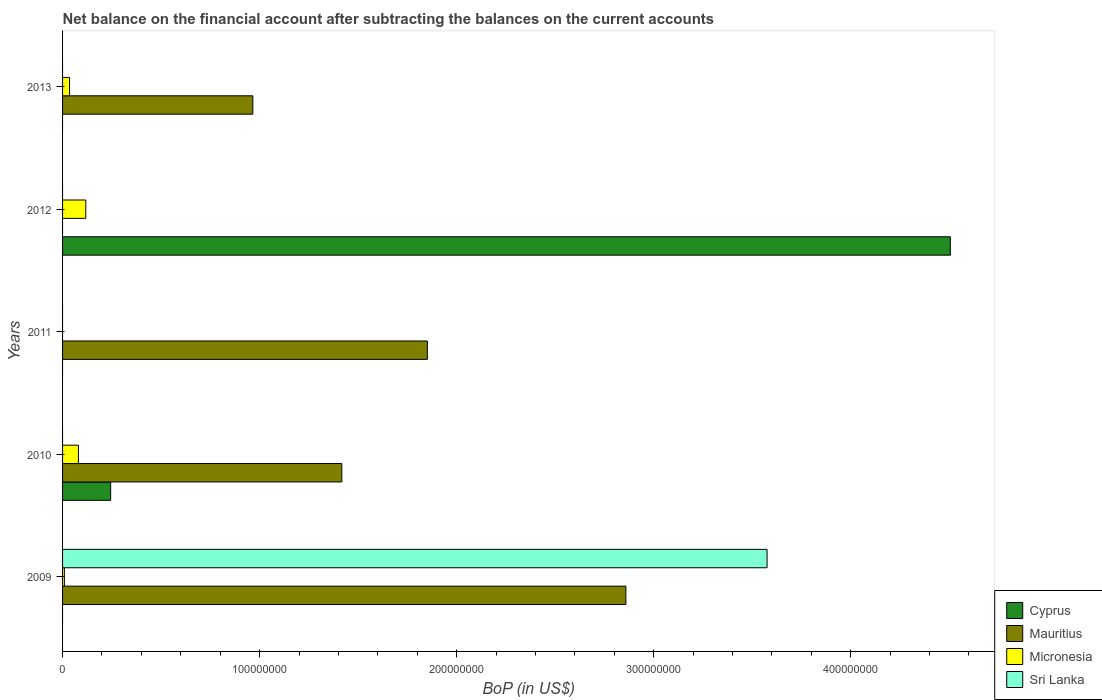How many bars are there on the 5th tick from the bottom?
Keep it short and to the point. 2. What is the label of the 5th group of bars from the top?
Make the answer very short. 2009. In how many cases, is the number of bars for a given year not equal to the number of legend labels?
Give a very brief answer. 5. Across all years, what is the maximum Balance of Payments in Mauritius?
Provide a short and direct response. 2.86e+08. Across all years, what is the minimum Balance of Payments in Sri Lanka?
Keep it short and to the point. 0. What is the total Balance of Payments in Sri Lanka in the graph?
Give a very brief answer. 3.58e+08. What is the difference between the Balance of Payments in Micronesia in 2009 and that in 2010?
Ensure brevity in your answer.  -7.13e+06. What is the difference between the Balance of Payments in Cyprus in 2011 and the Balance of Payments in Micronesia in 2013?
Offer a terse response. -3.55e+06. What is the average Balance of Payments in Mauritius per year?
Offer a very short reply. 1.42e+08. In the year 2010, what is the difference between the Balance of Payments in Mauritius and Balance of Payments in Cyprus?
Give a very brief answer. 1.17e+08. What is the ratio of the Balance of Payments in Mauritius in 2010 to that in 2011?
Provide a short and direct response. 0.77. Is the Balance of Payments in Mauritius in 2010 less than that in 2013?
Keep it short and to the point. No. What is the difference between the highest and the second highest Balance of Payments in Mauritius?
Give a very brief answer. 1.01e+08. What is the difference between the highest and the lowest Balance of Payments in Cyprus?
Your answer should be compact. 4.51e+08. In how many years, is the Balance of Payments in Sri Lanka greater than the average Balance of Payments in Sri Lanka taken over all years?
Offer a terse response. 1. Is it the case that in every year, the sum of the Balance of Payments in Micronesia and Balance of Payments in Sri Lanka is greater than the sum of Balance of Payments in Cyprus and Balance of Payments in Mauritius?
Make the answer very short. No. How many bars are there?
Provide a succinct answer. 11. Are all the bars in the graph horizontal?
Offer a very short reply. Yes. How many years are there in the graph?
Provide a short and direct response. 5. Where does the legend appear in the graph?
Your response must be concise. Bottom right. How many legend labels are there?
Provide a succinct answer. 4. What is the title of the graph?
Ensure brevity in your answer.  Net balance on the financial account after subtracting the balances on the current accounts. Does "Chile" appear as one of the legend labels in the graph?
Make the answer very short. No. What is the label or title of the X-axis?
Keep it short and to the point. BoP (in US$). What is the BoP (in US$) of Mauritius in 2009?
Provide a short and direct response. 2.86e+08. What is the BoP (in US$) of Micronesia in 2009?
Keep it short and to the point. 9.18e+05. What is the BoP (in US$) in Sri Lanka in 2009?
Your answer should be very brief. 3.58e+08. What is the BoP (in US$) in Cyprus in 2010?
Ensure brevity in your answer.  2.44e+07. What is the BoP (in US$) of Mauritius in 2010?
Offer a very short reply. 1.42e+08. What is the BoP (in US$) of Micronesia in 2010?
Make the answer very short. 8.05e+06. What is the BoP (in US$) of Sri Lanka in 2010?
Offer a very short reply. 0. What is the BoP (in US$) in Mauritius in 2011?
Give a very brief answer. 1.85e+08. What is the BoP (in US$) in Cyprus in 2012?
Your answer should be compact. 4.51e+08. What is the BoP (in US$) of Mauritius in 2012?
Your answer should be compact. 0. What is the BoP (in US$) of Micronesia in 2012?
Your answer should be compact. 1.18e+07. What is the BoP (in US$) of Sri Lanka in 2012?
Give a very brief answer. 0. What is the BoP (in US$) in Mauritius in 2013?
Make the answer very short. 9.66e+07. What is the BoP (in US$) of Micronesia in 2013?
Your answer should be very brief. 3.55e+06. What is the BoP (in US$) in Sri Lanka in 2013?
Offer a very short reply. 0. Across all years, what is the maximum BoP (in US$) in Cyprus?
Your answer should be very brief. 4.51e+08. Across all years, what is the maximum BoP (in US$) of Mauritius?
Offer a terse response. 2.86e+08. Across all years, what is the maximum BoP (in US$) in Micronesia?
Make the answer very short. 1.18e+07. Across all years, what is the maximum BoP (in US$) of Sri Lanka?
Provide a short and direct response. 3.58e+08. Across all years, what is the minimum BoP (in US$) in Cyprus?
Provide a succinct answer. 0. Across all years, what is the minimum BoP (in US$) in Micronesia?
Keep it short and to the point. 0. What is the total BoP (in US$) in Cyprus in the graph?
Your response must be concise. 4.75e+08. What is the total BoP (in US$) of Mauritius in the graph?
Keep it short and to the point. 7.09e+08. What is the total BoP (in US$) in Micronesia in the graph?
Your answer should be compact. 2.43e+07. What is the total BoP (in US$) in Sri Lanka in the graph?
Offer a very short reply. 3.58e+08. What is the difference between the BoP (in US$) of Mauritius in 2009 and that in 2010?
Your answer should be compact. 1.44e+08. What is the difference between the BoP (in US$) of Micronesia in 2009 and that in 2010?
Keep it short and to the point. -7.13e+06. What is the difference between the BoP (in US$) of Mauritius in 2009 and that in 2011?
Provide a succinct answer. 1.01e+08. What is the difference between the BoP (in US$) of Micronesia in 2009 and that in 2012?
Make the answer very short. -1.09e+07. What is the difference between the BoP (in US$) of Mauritius in 2009 and that in 2013?
Give a very brief answer. 1.89e+08. What is the difference between the BoP (in US$) of Micronesia in 2009 and that in 2013?
Offer a terse response. -2.63e+06. What is the difference between the BoP (in US$) of Mauritius in 2010 and that in 2011?
Offer a very short reply. -4.34e+07. What is the difference between the BoP (in US$) of Cyprus in 2010 and that in 2012?
Make the answer very short. -4.26e+08. What is the difference between the BoP (in US$) of Micronesia in 2010 and that in 2012?
Provide a succinct answer. -3.73e+06. What is the difference between the BoP (in US$) in Mauritius in 2010 and that in 2013?
Make the answer very short. 4.52e+07. What is the difference between the BoP (in US$) of Micronesia in 2010 and that in 2013?
Your answer should be very brief. 4.50e+06. What is the difference between the BoP (in US$) of Mauritius in 2011 and that in 2013?
Ensure brevity in your answer.  8.86e+07. What is the difference between the BoP (in US$) of Micronesia in 2012 and that in 2013?
Offer a terse response. 8.23e+06. What is the difference between the BoP (in US$) in Mauritius in 2009 and the BoP (in US$) in Micronesia in 2010?
Provide a succinct answer. 2.78e+08. What is the difference between the BoP (in US$) of Mauritius in 2009 and the BoP (in US$) of Micronesia in 2012?
Make the answer very short. 2.74e+08. What is the difference between the BoP (in US$) in Mauritius in 2009 and the BoP (in US$) in Micronesia in 2013?
Provide a short and direct response. 2.82e+08. What is the difference between the BoP (in US$) of Cyprus in 2010 and the BoP (in US$) of Mauritius in 2011?
Offer a terse response. -1.61e+08. What is the difference between the BoP (in US$) in Cyprus in 2010 and the BoP (in US$) in Micronesia in 2012?
Your answer should be compact. 1.26e+07. What is the difference between the BoP (in US$) in Mauritius in 2010 and the BoP (in US$) in Micronesia in 2012?
Provide a succinct answer. 1.30e+08. What is the difference between the BoP (in US$) of Cyprus in 2010 and the BoP (in US$) of Mauritius in 2013?
Your answer should be compact. -7.22e+07. What is the difference between the BoP (in US$) of Cyprus in 2010 and the BoP (in US$) of Micronesia in 2013?
Ensure brevity in your answer.  2.09e+07. What is the difference between the BoP (in US$) in Mauritius in 2010 and the BoP (in US$) in Micronesia in 2013?
Offer a terse response. 1.38e+08. What is the difference between the BoP (in US$) in Mauritius in 2011 and the BoP (in US$) in Micronesia in 2012?
Provide a short and direct response. 1.73e+08. What is the difference between the BoP (in US$) of Mauritius in 2011 and the BoP (in US$) of Micronesia in 2013?
Your answer should be compact. 1.82e+08. What is the difference between the BoP (in US$) of Cyprus in 2012 and the BoP (in US$) of Mauritius in 2013?
Your answer should be very brief. 3.54e+08. What is the difference between the BoP (in US$) of Cyprus in 2012 and the BoP (in US$) of Micronesia in 2013?
Offer a terse response. 4.47e+08. What is the average BoP (in US$) in Cyprus per year?
Provide a short and direct response. 9.50e+07. What is the average BoP (in US$) of Mauritius per year?
Offer a very short reply. 1.42e+08. What is the average BoP (in US$) in Micronesia per year?
Provide a short and direct response. 4.86e+06. What is the average BoP (in US$) of Sri Lanka per year?
Ensure brevity in your answer.  7.15e+07. In the year 2009, what is the difference between the BoP (in US$) in Mauritius and BoP (in US$) in Micronesia?
Your answer should be compact. 2.85e+08. In the year 2009, what is the difference between the BoP (in US$) of Mauritius and BoP (in US$) of Sri Lanka?
Offer a very short reply. -7.17e+07. In the year 2009, what is the difference between the BoP (in US$) of Micronesia and BoP (in US$) of Sri Lanka?
Your answer should be compact. -3.57e+08. In the year 2010, what is the difference between the BoP (in US$) in Cyprus and BoP (in US$) in Mauritius?
Offer a very short reply. -1.17e+08. In the year 2010, what is the difference between the BoP (in US$) in Cyprus and BoP (in US$) in Micronesia?
Offer a terse response. 1.64e+07. In the year 2010, what is the difference between the BoP (in US$) in Mauritius and BoP (in US$) in Micronesia?
Provide a short and direct response. 1.34e+08. In the year 2012, what is the difference between the BoP (in US$) of Cyprus and BoP (in US$) of Micronesia?
Your response must be concise. 4.39e+08. In the year 2013, what is the difference between the BoP (in US$) in Mauritius and BoP (in US$) in Micronesia?
Your response must be concise. 9.30e+07. What is the ratio of the BoP (in US$) in Mauritius in 2009 to that in 2010?
Provide a succinct answer. 2.02. What is the ratio of the BoP (in US$) of Micronesia in 2009 to that in 2010?
Make the answer very short. 0.11. What is the ratio of the BoP (in US$) of Mauritius in 2009 to that in 2011?
Make the answer very short. 1.54. What is the ratio of the BoP (in US$) of Micronesia in 2009 to that in 2012?
Your answer should be compact. 0.08. What is the ratio of the BoP (in US$) in Mauritius in 2009 to that in 2013?
Offer a terse response. 2.96. What is the ratio of the BoP (in US$) in Micronesia in 2009 to that in 2013?
Ensure brevity in your answer.  0.26. What is the ratio of the BoP (in US$) of Mauritius in 2010 to that in 2011?
Keep it short and to the point. 0.77. What is the ratio of the BoP (in US$) of Cyprus in 2010 to that in 2012?
Your response must be concise. 0.05. What is the ratio of the BoP (in US$) of Micronesia in 2010 to that in 2012?
Ensure brevity in your answer.  0.68. What is the ratio of the BoP (in US$) of Mauritius in 2010 to that in 2013?
Make the answer very short. 1.47. What is the ratio of the BoP (in US$) of Micronesia in 2010 to that in 2013?
Offer a very short reply. 2.27. What is the ratio of the BoP (in US$) of Mauritius in 2011 to that in 2013?
Your answer should be very brief. 1.92. What is the ratio of the BoP (in US$) in Micronesia in 2012 to that in 2013?
Make the answer very short. 3.32. What is the difference between the highest and the second highest BoP (in US$) of Mauritius?
Give a very brief answer. 1.01e+08. What is the difference between the highest and the second highest BoP (in US$) in Micronesia?
Your answer should be compact. 3.73e+06. What is the difference between the highest and the lowest BoP (in US$) in Cyprus?
Your answer should be compact. 4.51e+08. What is the difference between the highest and the lowest BoP (in US$) of Mauritius?
Make the answer very short. 2.86e+08. What is the difference between the highest and the lowest BoP (in US$) of Micronesia?
Make the answer very short. 1.18e+07. What is the difference between the highest and the lowest BoP (in US$) in Sri Lanka?
Ensure brevity in your answer.  3.58e+08. 